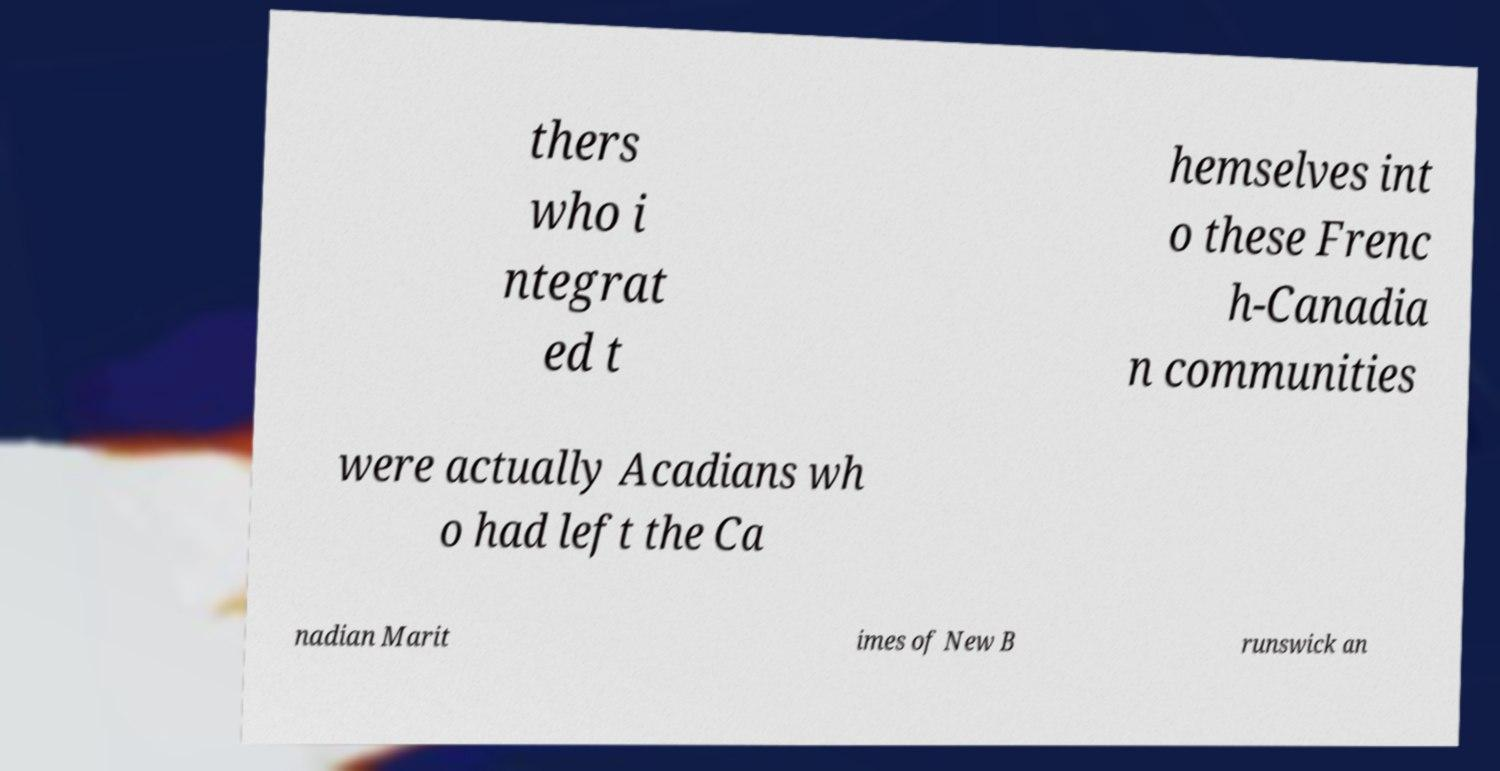Could you extract and type out the text from this image? thers who i ntegrat ed t hemselves int o these Frenc h-Canadia n communities were actually Acadians wh o had left the Ca nadian Marit imes of New B runswick an 